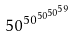<formula> <loc_0><loc_0><loc_500><loc_500>5 0 ^ { 5 0 ^ { 5 0 ^ { 5 0 ^ { 5 9 } } } }</formula> 